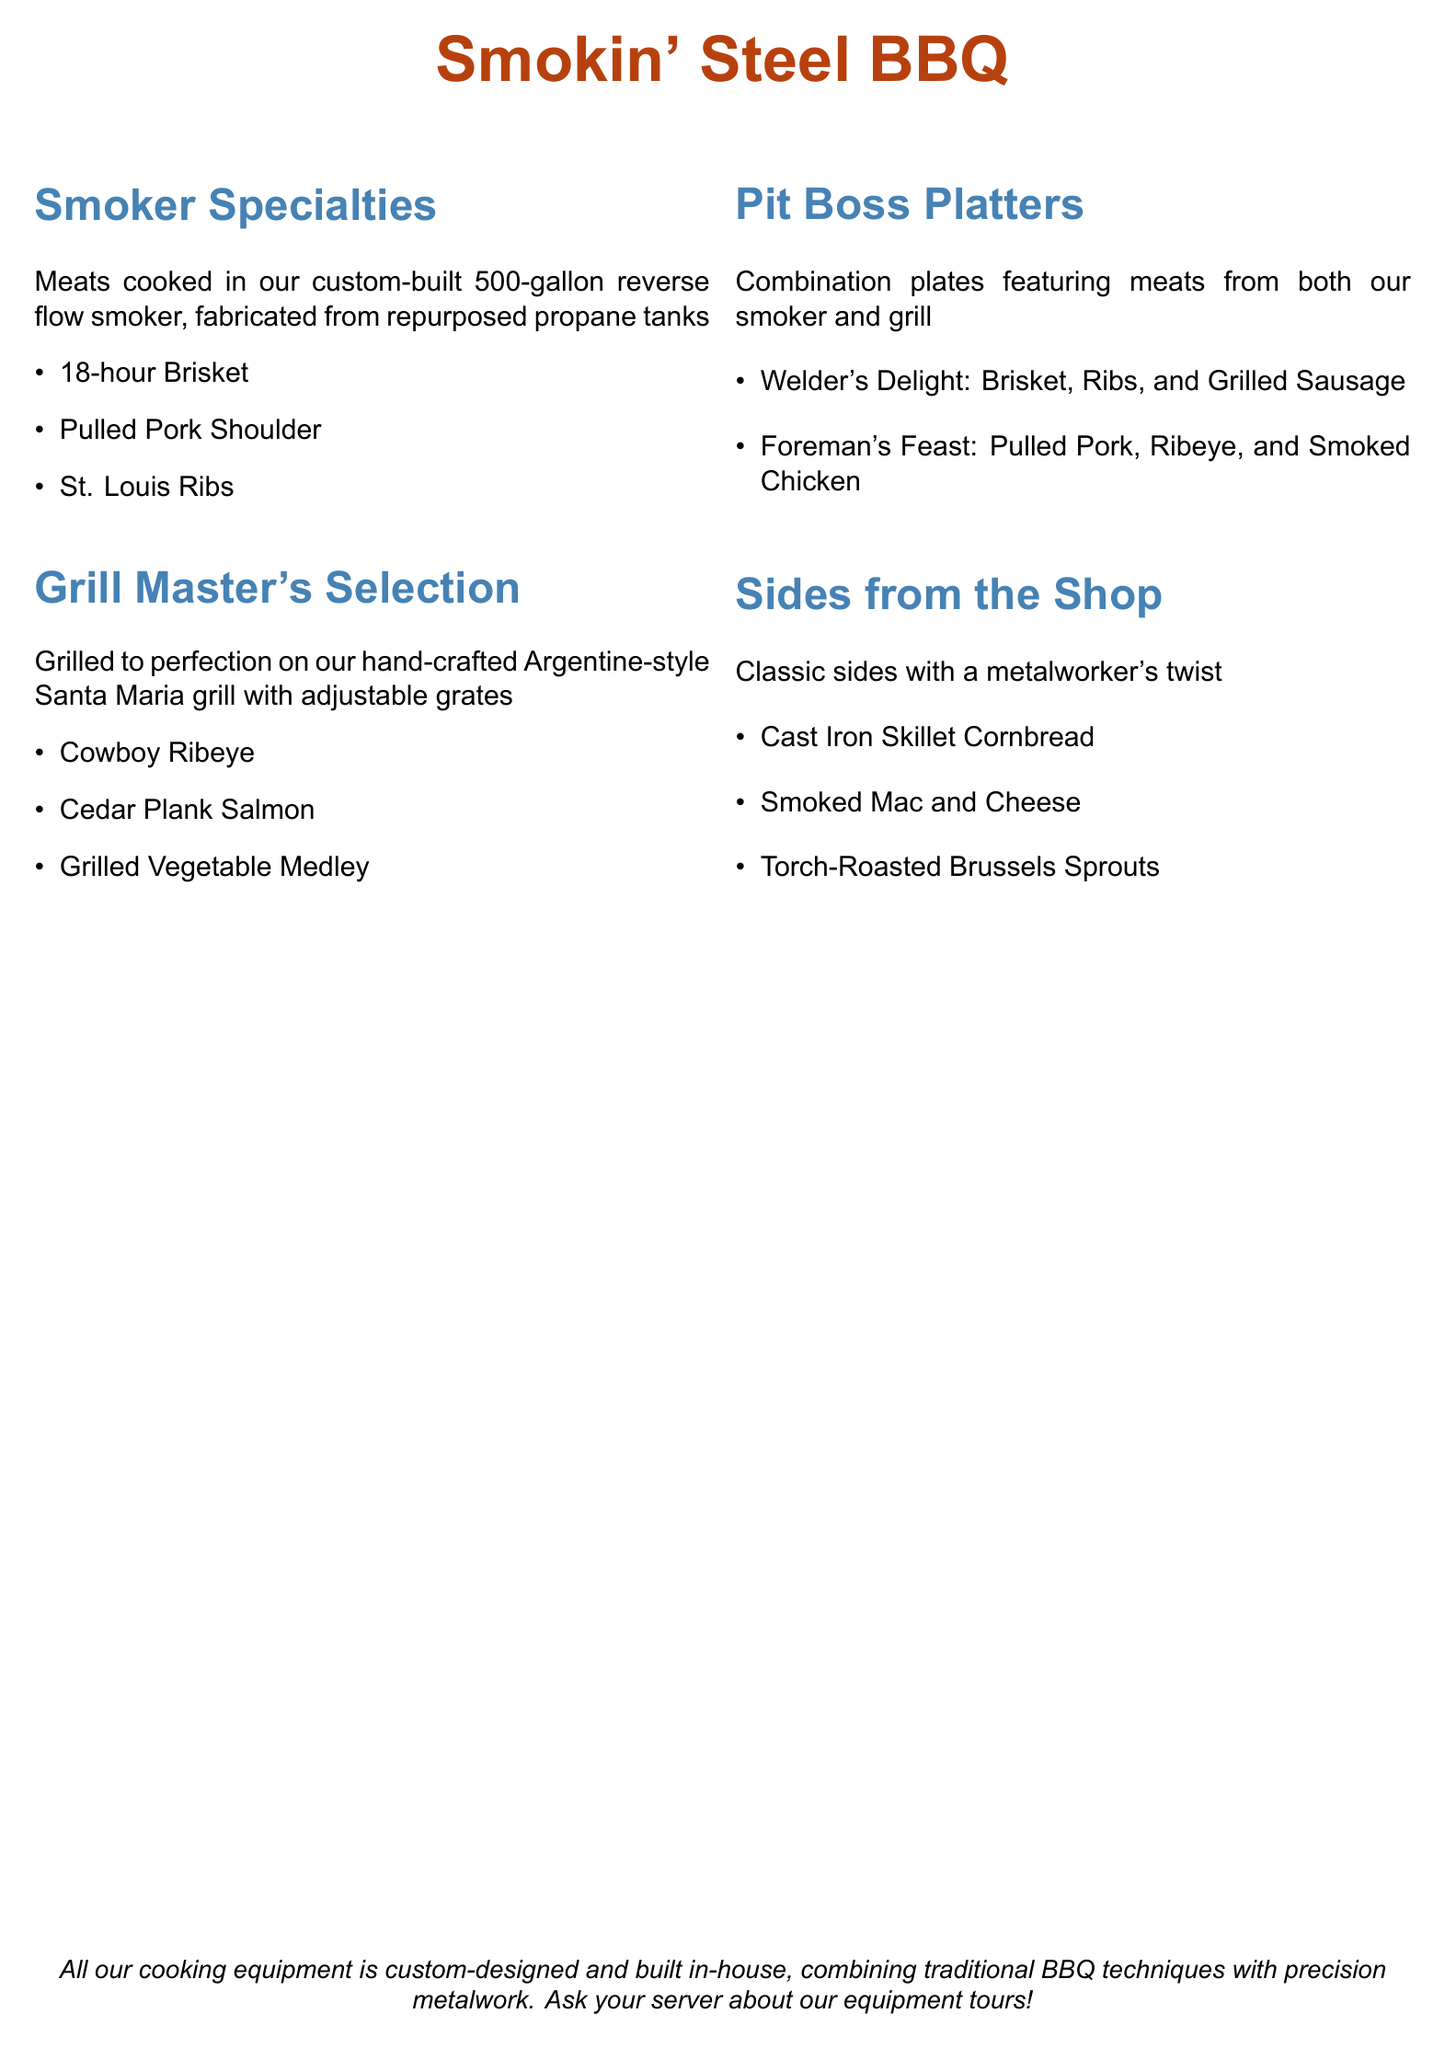What type of smoker is used at Smokin' Steel BBQ? The document mentions that meats are cooked in a custom-built 500-gallon reverse flow smoker.
Answer: reverse flow smoker What is the primary material used for the smoker's construction? The document states that the smoker is fabricated from repurposed propane tanks.
Answer: repurposed propane tanks Which grilling style is highlighted in the menu? The menu features hand-crafted Argentine-style Santa Maria grill for grilling.
Answer: Argentine-style Santa Maria grill How many types of meats are listed under Smoker Specialties? There are three types of meats mentioned in the Smoker Specialties section.
Answer: 3 What is the name of a specific combination plate featuring brisket? One of the Pit Boss Platters is named the Welder's Delight, which includes brisket.
Answer: Welder's Delight Which side item is described as being made in a specific cooking vessel? The menu notes that the cornbread is prepared in a cast iron skillet.
Answer: Cast Iron Skillet Cornbread How long is the brisket cooked for? The menu states that the brisket is cooked for 18 hours.
Answer: 18 hours What two cooking methods are combined in the Pit Boss Platters? The Pit Boss Platters feature meats from both the smoker and the grill, combining the two methods.
Answer: smoker and grill What does the menu encourage customers to ask their server about? The menu encourages customers to inquire about the equipment tours.
Answer: equipment tours 